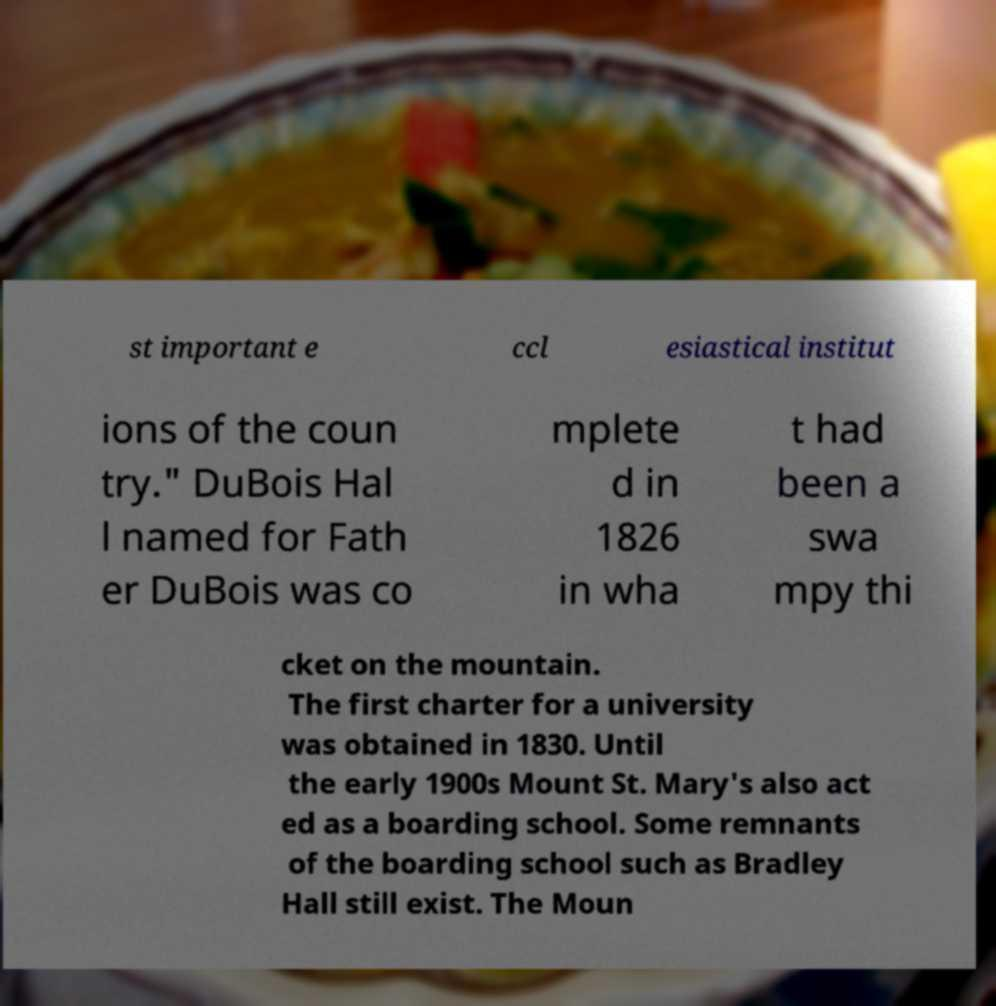Could you extract and type out the text from this image? st important e ccl esiastical institut ions of the coun try." DuBois Hal l named for Fath er DuBois was co mplete d in 1826 in wha t had been a swa mpy thi cket on the mountain. The first charter for a university was obtained in 1830. Until the early 1900s Mount St. Mary's also act ed as a boarding school. Some remnants of the boarding school such as Bradley Hall still exist. The Moun 